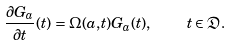Convert formula to latex. <formula><loc_0><loc_0><loc_500><loc_500>\frac { \partial G _ { a } } { \partial t } ( t ) = \Omega ( a , t ) G _ { a } ( t ) , \quad t \in \mathfrak { D } .</formula> 